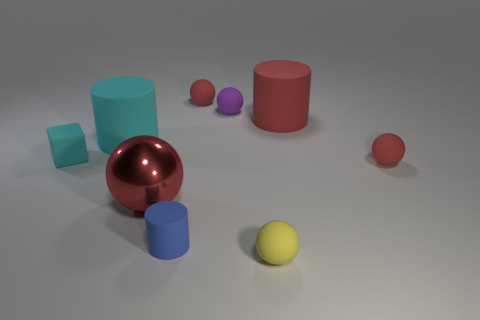Are there any other things of the same color as the tiny cylinder?
Make the answer very short. No. There is a sphere that is in front of the blue rubber cylinder; does it have the same size as the large metal ball?
Provide a short and direct response. No. Is the number of small yellow things that are to the left of the blue cylinder less than the number of big shiny spheres?
Provide a short and direct response. Yes. There is a ball that is the same size as the cyan matte cylinder; what is it made of?
Provide a succinct answer. Metal. How many big things are either red matte spheres or yellow balls?
Ensure brevity in your answer.  0. How many things are either balls behind the yellow thing or cylinders that are left of the large red sphere?
Offer a terse response. 5. Is the number of red rubber spheres less than the number of gray cylinders?
Offer a terse response. No. What shape is the yellow thing that is the same size as the cyan cube?
Give a very brief answer. Sphere. What number of other objects are the same color as the large shiny object?
Ensure brevity in your answer.  3. What number of large cyan metallic blocks are there?
Make the answer very short. 0. 